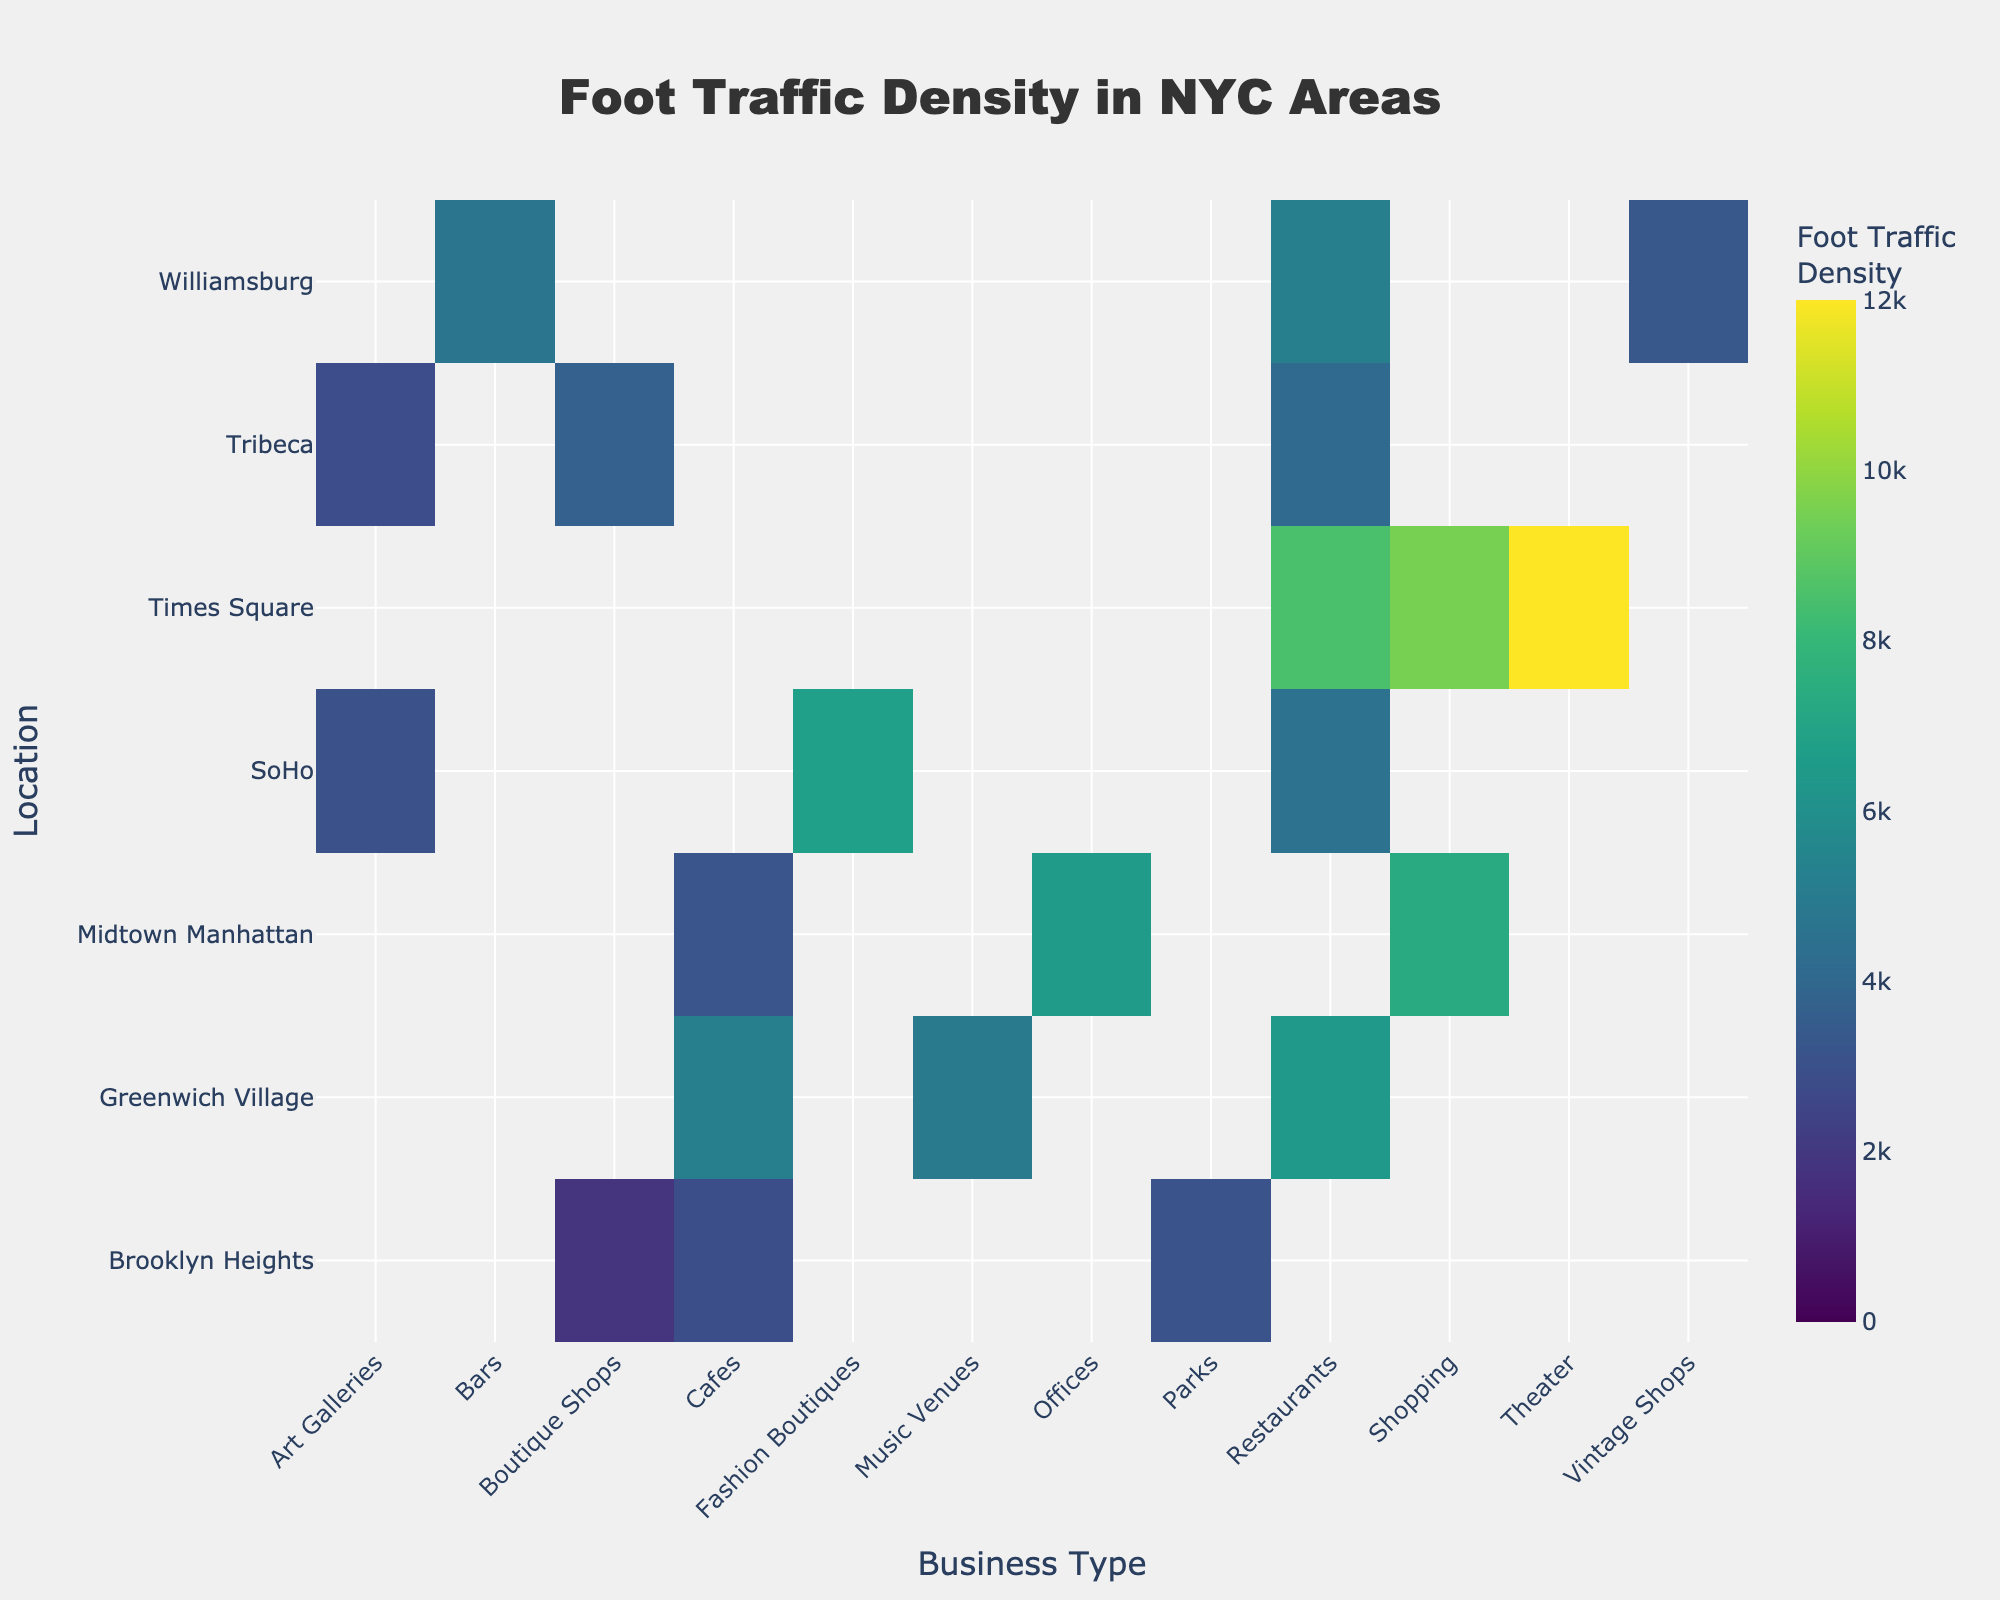what is the title of the Heatmap? The title is located at the top center of the heatmap and is typically the largest piece of text. The text reads "Foot Traffic Density in NYC Areas" which indicates what the heatmap is about.
Answer: Foot Traffic Density in NYC Areas Which location registers the highest foot traffic density for restaurants? Look at the intersection of 'Restaurants' column and each location row. The highest value is found at Times Square with a density of 8500.
Answer: Times Square How does the foot traffic density for Cafes in Greenwich Village compare to that in Brooklyn Heights? Check the intersection of 'Cafes' column and 'Greenwich Village' and 'Brooklyn Heights' rows. Greenwich Village shows 5200 while Brooklyn Heights shows 2900, indicating that Greenwich Village has a higher foot traffic density for Cafes.
Answer: Greenwich Village has higher traffic Which business type in Midtown Manhattan has the lowest foot traffic density? Look at the 'Midtown Manhattan' row and identify the smallest number. The lowest value is for 'Cafes' with a density of 3200.
Answer: Cafes What is the average foot traffic density of business types in Tribeca? Locate the 'Tribeca' row and sum the values for 'Restaurants', 'Boutique Shops', and 'Art Galleries' (4100 + 3700 + 2800) = 10600. Divide by the number of business types: 10600/3 = 3533.33
Answer: 3533.33 Which business type has the highest foot traffic density in SoHo? Look at the 'SoHo' row and find the highest number. The highest density is for 'Fashion Boutiques' with a value of 6700.
Answer: Fashion Boutiques Is foot traffic density generally higher for restaurants or cafes across all locations? Compare the 'Restaurants' and 'Cafes' columns across all locations. Add the values for each: Restaurants (8500 + 4100 + 5200 + 6400 + 4500) = 28700; Cafes (3200 + 2900 + 5200) = 11300. Restaurants have higher overall foot traffic density.
Answer: Restaurants How does the foot traffic density for shopping at Times Square compare to shopping in Midtown Manhattan? Look at the intersections of 'Shopping' column with 'Times Square' and 'Midtown Manhattan' rows. Times Square shows 9500 while Midtown Manhattan shows 7300, indicating that Times Square has higher foot traffic density for shopping.
Answer: Times Square has higher traffic What is the variance in foot traffic density amongst the business types in Williamsburg? Identify the numbers for 'Williamsburg' row: Restaurants (5200), Bars (4700), Vintage Shops (3300). Variance formula: [(5200-4400)^2 + (4700-4400)^2 + (3300-4400)^2] / 3 = [(640000) + (810000) + (1210000)] / 3 = 889000.
Answer: 889000 Which locations have more than one type of business with a foot traffic density greater than 5000? Check each location row for counts of values greater than 5000. Times Square and Greenwich Village both have multiple business types with densities over 5000.
Answer: Times Square, Greenwich Village 